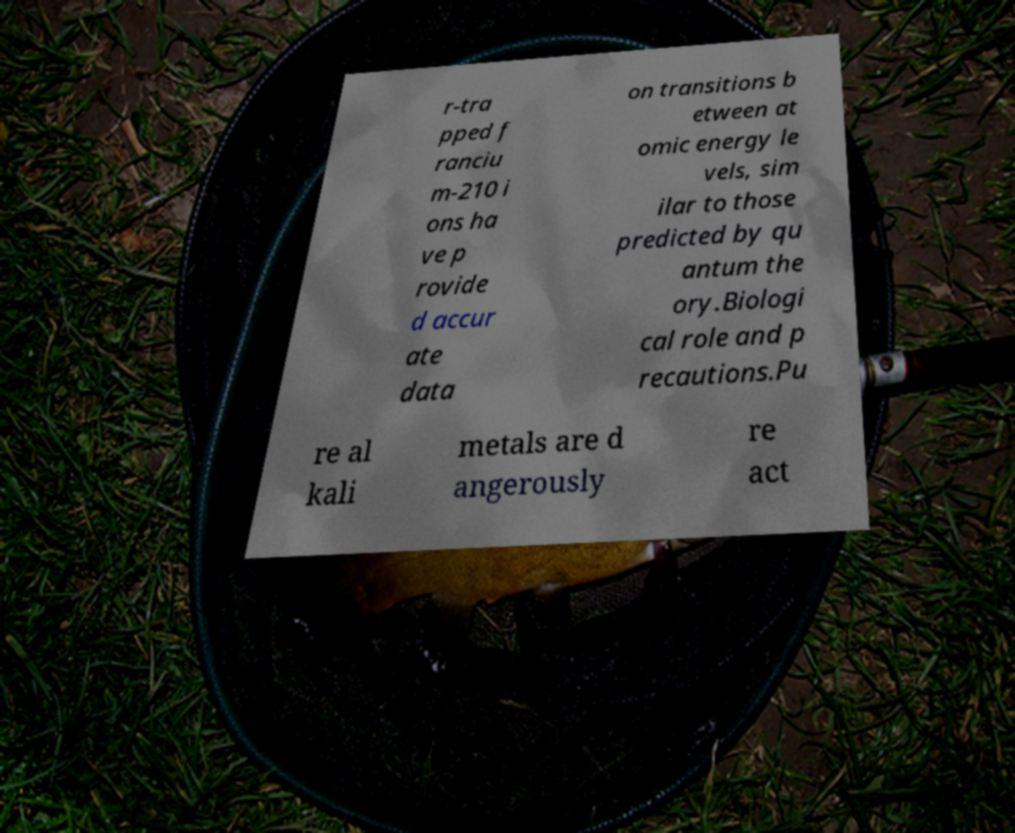There's text embedded in this image that I need extracted. Can you transcribe it verbatim? r-tra pped f ranciu m-210 i ons ha ve p rovide d accur ate data on transitions b etween at omic energy le vels, sim ilar to those predicted by qu antum the ory.Biologi cal role and p recautions.Pu re al kali metals are d angerously re act 